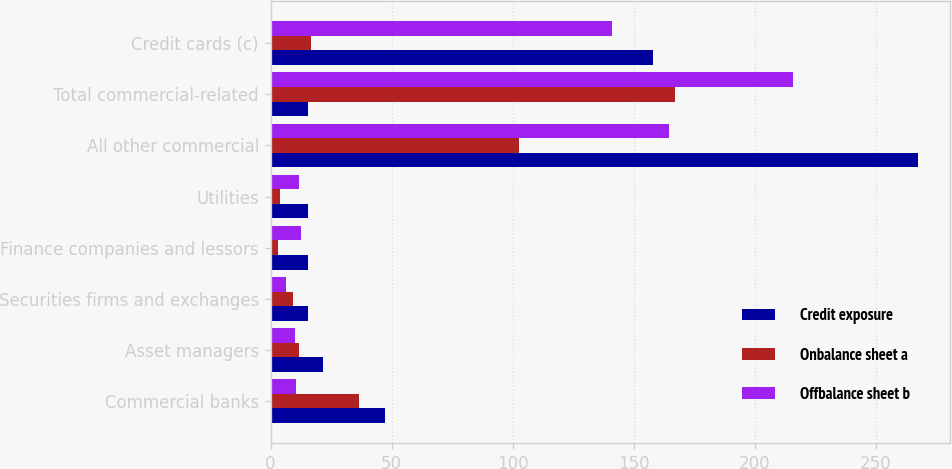Convert chart. <chart><loc_0><loc_0><loc_500><loc_500><stacked_bar_chart><ecel><fcel>Commercial banks<fcel>Asset managers<fcel>Securities firms and exchanges<fcel>Finance companies and lessors<fcel>Utilities<fcel>All other commercial<fcel>Total commercial-related<fcel>Credit cards (c)<nl><fcel>Credit exposure<fcel>47.1<fcel>21.8<fcel>15.6<fcel>15.6<fcel>15.3<fcel>267.3<fcel>15.6<fcel>157.9<nl><fcel>Onbalance sheet a<fcel>36.5<fcel>11.7<fcel>9.3<fcel>3.1<fcel>3.7<fcel>102.7<fcel>167<fcel>16.8<nl><fcel>Offbalance sheet b<fcel>10.6<fcel>10.1<fcel>6.3<fcel>12.5<fcel>11.6<fcel>164.6<fcel>215.7<fcel>141.1<nl></chart> 